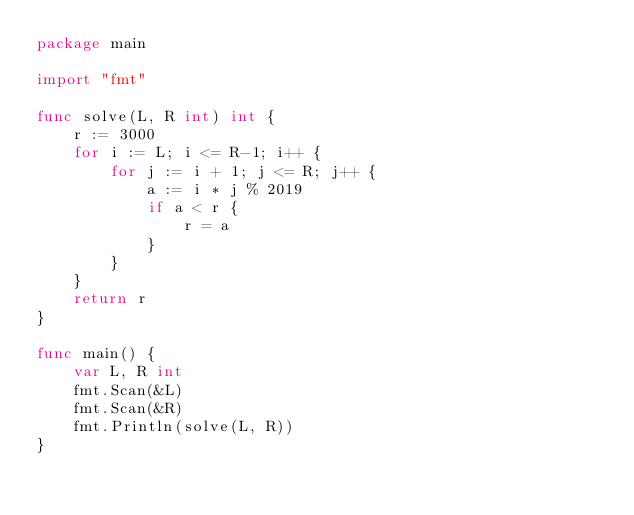Convert code to text. <code><loc_0><loc_0><loc_500><loc_500><_Go_>package main

import "fmt"

func solve(L, R int) int {
	r := 3000
	for i := L; i <= R-1; i++ {
		for j := i + 1; j <= R; j++ {
			a := i * j % 2019
			if a < r {
				r = a
			}
		}
	}
	return r
}

func main() {
	var L, R int
	fmt.Scan(&L)
	fmt.Scan(&R)
	fmt.Println(solve(L, R))
}</code> 